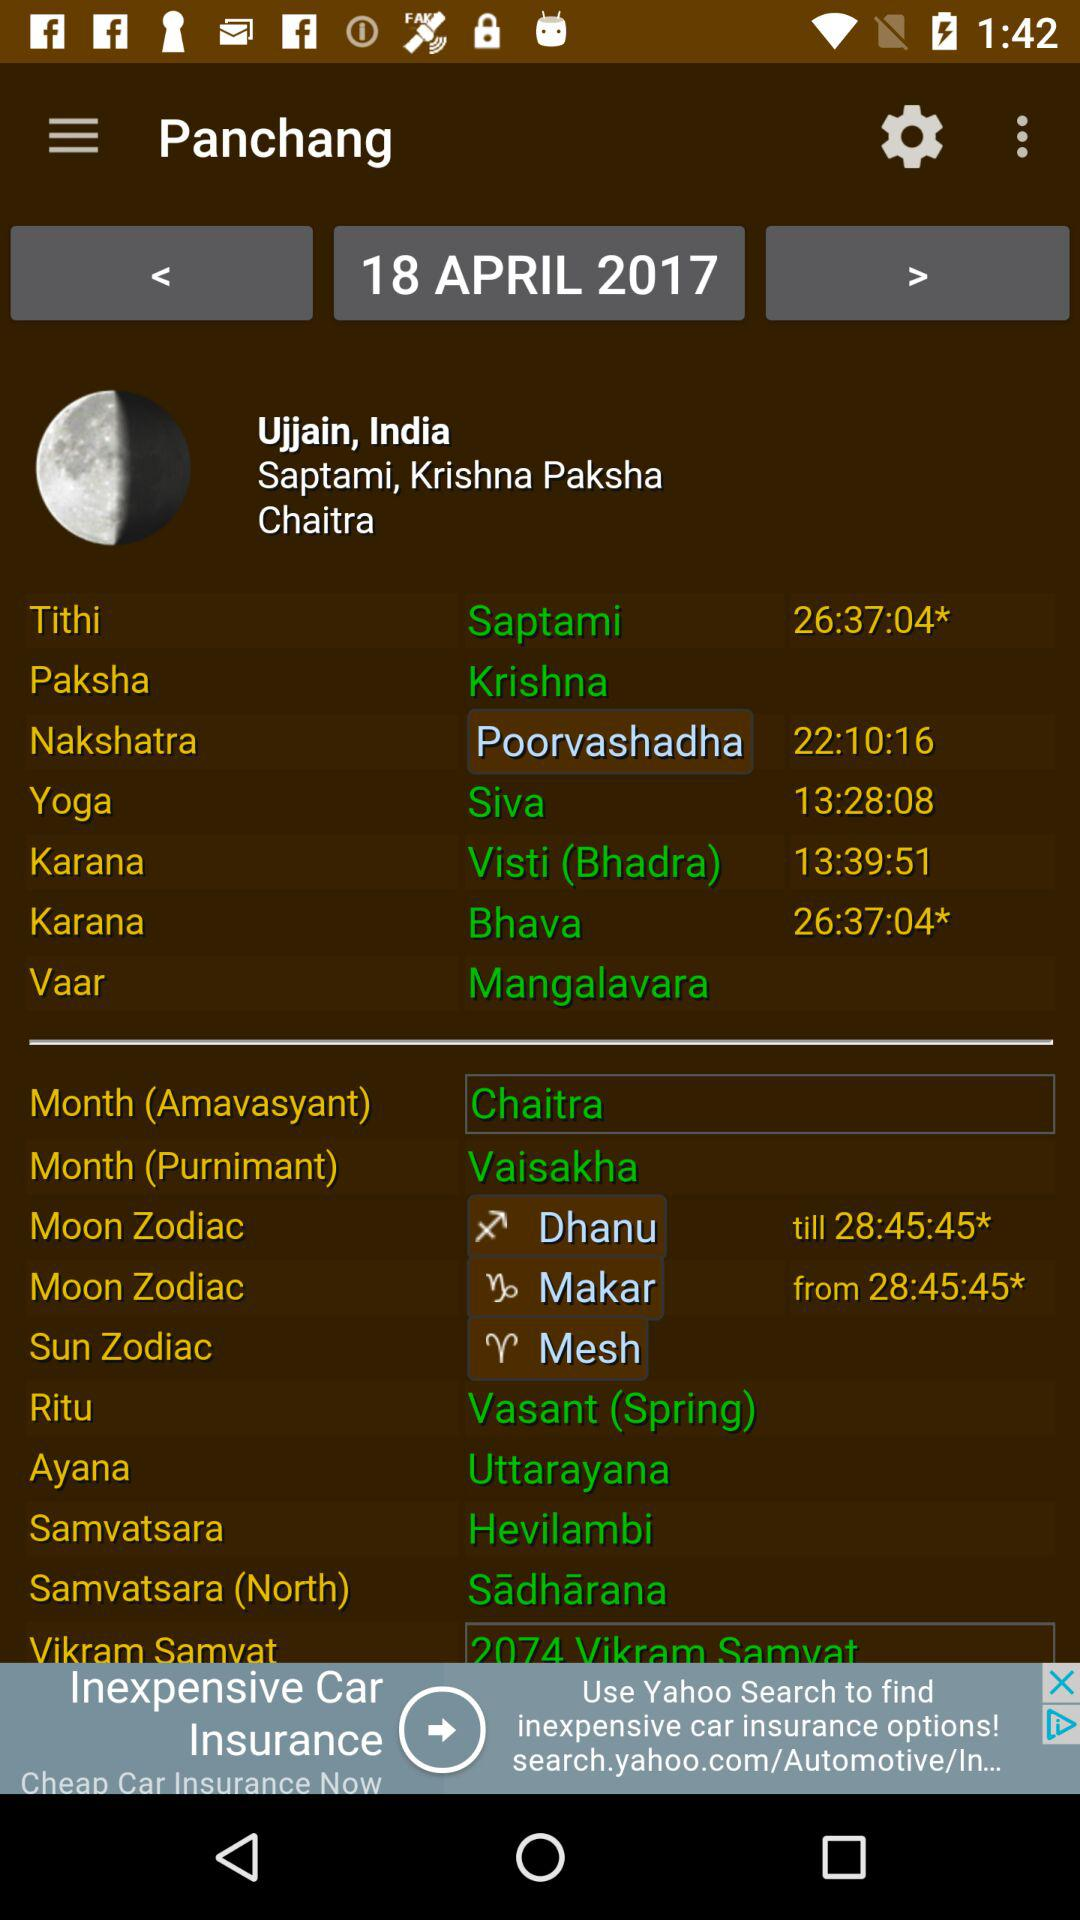What is the "Ayana"? The "Ayana" is Uttarayana. 